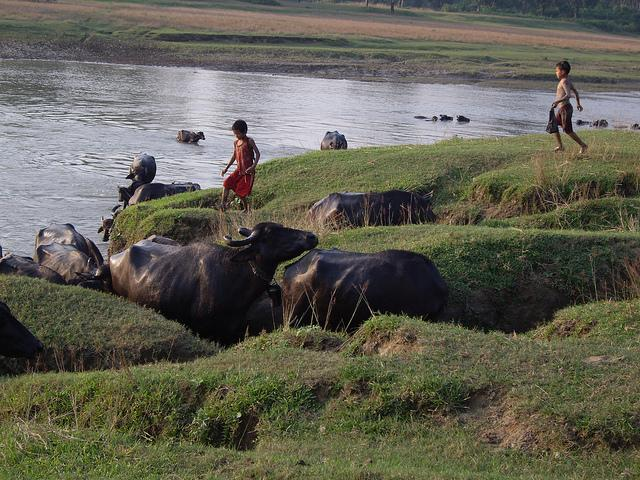How many children are running onto the cape with the water cows? two 